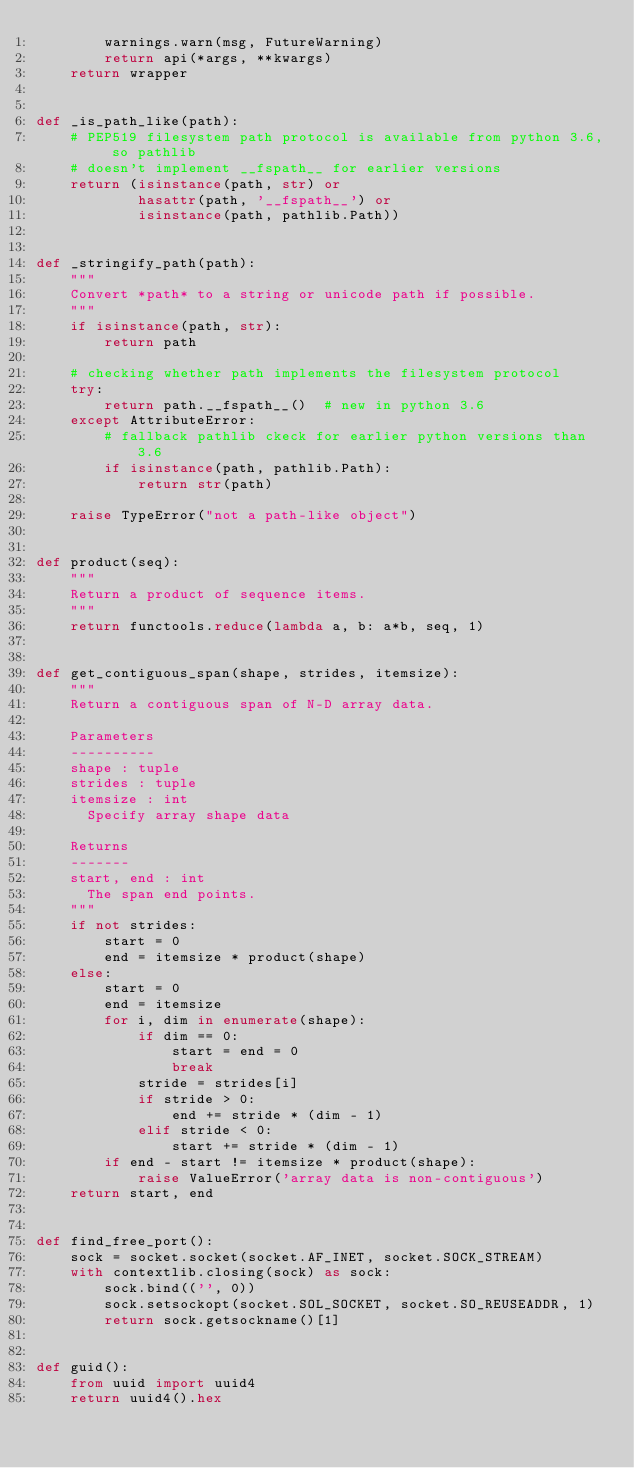<code> <loc_0><loc_0><loc_500><loc_500><_Python_>        warnings.warn(msg, FutureWarning)
        return api(*args, **kwargs)
    return wrapper


def _is_path_like(path):
    # PEP519 filesystem path protocol is available from python 3.6, so pathlib
    # doesn't implement __fspath__ for earlier versions
    return (isinstance(path, str) or
            hasattr(path, '__fspath__') or
            isinstance(path, pathlib.Path))


def _stringify_path(path):
    """
    Convert *path* to a string or unicode path if possible.
    """
    if isinstance(path, str):
        return path

    # checking whether path implements the filesystem protocol
    try:
        return path.__fspath__()  # new in python 3.6
    except AttributeError:
        # fallback pathlib ckeck for earlier python versions than 3.6
        if isinstance(path, pathlib.Path):
            return str(path)

    raise TypeError("not a path-like object")


def product(seq):
    """
    Return a product of sequence items.
    """
    return functools.reduce(lambda a, b: a*b, seq, 1)


def get_contiguous_span(shape, strides, itemsize):
    """
    Return a contiguous span of N-D array data.

    Parameters
    ----------
    shape : tuple
    strides : tuple
    itemsize : int
      Specify array shape data

    Returns
    -------
    start, end : int
      The span end points.
    """
    if not strides:
        start = 0
        end = itemsize * product(shape)
    else:
        start = 0
        end = itemsize
        for i, dim in enumerate(shape):
            if dim == 0:
                start = end = 0
                break
            stride = strides[i]
            if stride > 0:
                end += stride * (dim - 1)
            elif stride < 0:
                start += stride * (dim - 1)
        if end - start != itemsize * product(shape):
            raise ValueError('array data is non-contiguous')
    return start, end


def find_free_port():
    sock = socket.socket(socket.AF_INET, socket.SOCK_STREAM)
    with contextlib.closing(sock) as sock:
        sock.bind(('', 0))
        sock.setsockopt(socket.SOL_SOCKET, socket.SO_REUSEADDR, 1)
        return sock.getsockname()[1]


def guid():
    from uuid import uuid4
    return uuid4().hex
</code> 